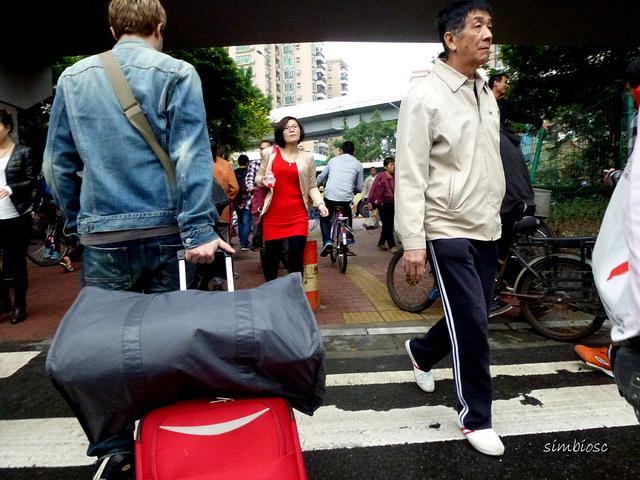Are there people?
Write a very short answer. Yes. Are there any bicycles in this picture?
Concise answer only. Yes. How much luggage is he carrying?
Keep it brief. 2 bags. 